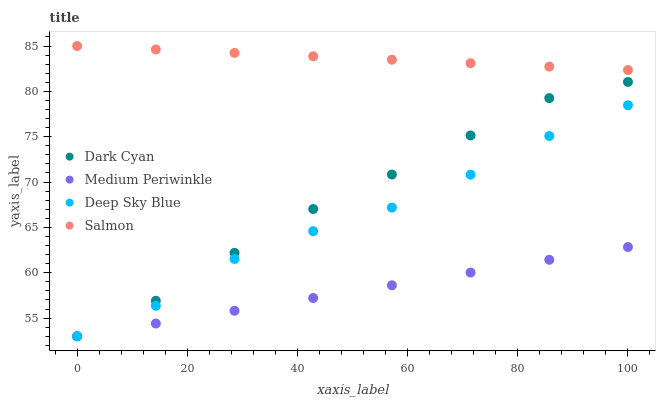Does Medium Periwinkle have the minimum area under the curve?
Answer yes or no. Yes. Does Salmon have the maximum area under the curve?
Answer yes or no. Yes. Does Salmon have the minimum area under the curve?
Answer yes or no. No. Does Medium Periwinkle have the maximum area under the curve?
Answer yes or no. No. Is Medium Periwinkle the smoothest?
Answer yes or no. Yes. Is Deep Sky Blue the roughest?
Answer yes or no. Yes. Is Salmon the smoothest?
Answer yes or no. No. Is Salmon the roughest?
Answer yes or no. No. Does Dark Cyan have the lowest value?
Answer yes or no. Yes. Does Salmon have the lowest value?
Answer yes or no. No. Does Salmon have the highest value?
Answer yes or no. Yes. Does Medium Periwinkle have the highest value?
Answer yes or no. No. Is Medium Periwinkle less than Salmon?
Answer yes or no. Yes. Is Salmon greater than Medium Periwinkle?
Answer yes or no. Yes. Does Medium Periwinkle intersect Dark Cyan?
Answer yes or no. Yes. Is Medium Periwinkle less than Dark Cyan?
Answer yes or no. No. Is Medium Periwinkle greater than Dark Cyan?
Answer yes or no. No. Does Medium Periwinkle intersect Salmon?
Answer yes or no. No. 